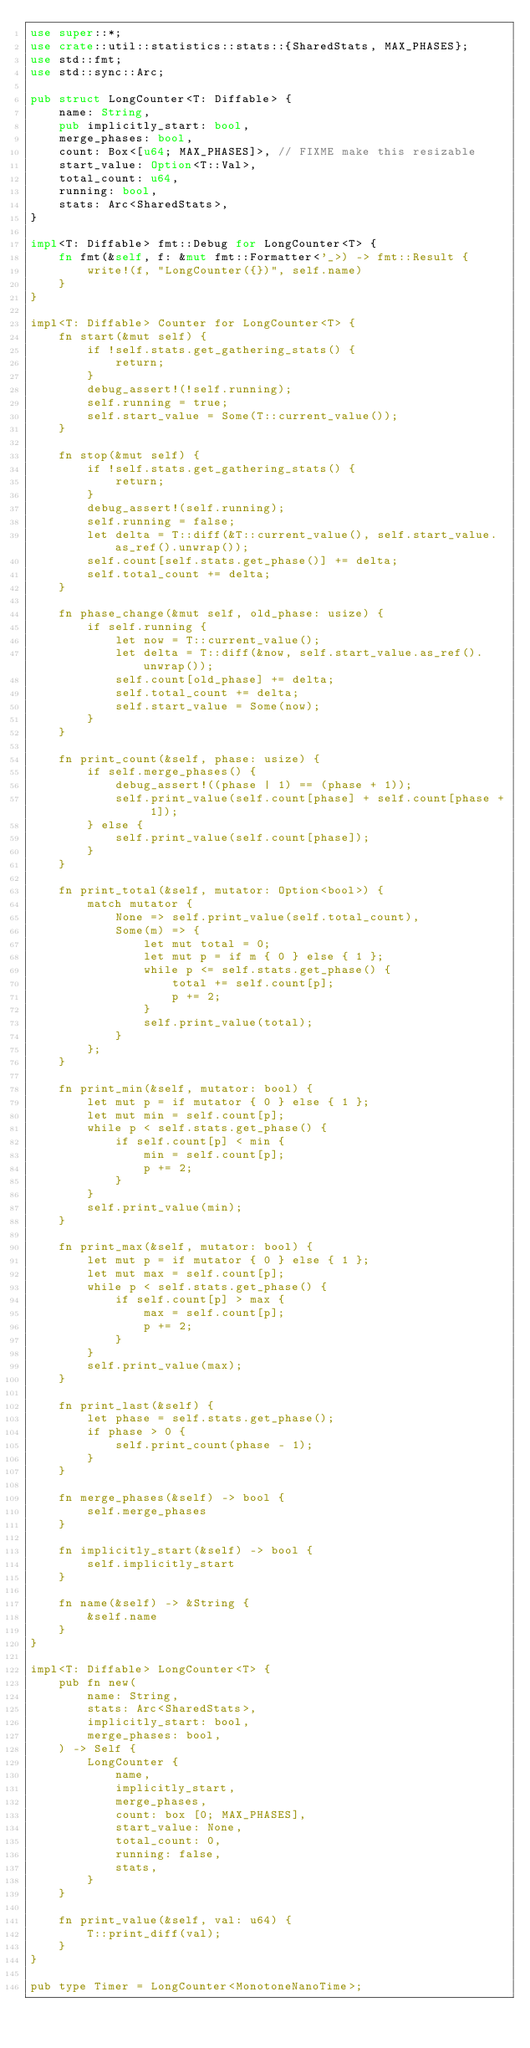Convert code to text. <code><loc_0><loc_0><loc_500><loc_500><_Rust_>use super::*;
use crate::util::statistics::stats::{SharedStats, MAX_PHASES};
use std::fmt;
use std::sync::Arc;

pub struct LongCounter<T: Diffable> {
    name: String,
    pub implicitly_start: bool,
    merge_phases: bool,
    count: Box<[u64; MAX_PHASES]>, // FIXME make this resizable
    start_value: Option<T::Val>,
    total_count: u64,
    running: bool,
    stats: Arc<SharedStats>,
}

impl<T: Diffable> fmt::Debug for LongCounter<T> {
    fn fmt(&self, f: &mut fmt::Formatter<'_>) -> fmt::Result {
        write!(f, "LongCounter({})", self.name)
    }
}

impl<T: Diffable> Counter for LongCounter<T> {
    fn start(&mut self) {
        if !self.stats.get_gathering_stats() {
            return;
        }
        debug_assert!(!self.running);
        self.running = true;
        self.start_value = Some(T::current_value());
    }

    fn stop(&mut self) {
        if !self.stats.get_gathering_stats() {
            return;
        }
        debug_assert!(self.running);
        self.running = false;
        let delta = T::diff(&T::current_value(), self.start_value.as_ref().unwrap());
        self.count[self.stats.get_phase()] += delta;
        self.total_count += delta;
    }

    fn phase_change(&mut self, old_phase: usize) {
        if self.running {
            let now = T::current_value();
            let delta = T::diff(&now, self.start_value.as_ref().unwrap());
            self.count[old_phase] += delta;
            self.total_count += delta;
            self.start_value = Some(now);
        }
    }

    fn print_count(&self, phase: usize) {
        if self.merge_phases() {
            debug_assert!((phase | 1) == (phase + 1));
            self.print_value(self.count[phase] + self.count[phase + 1]);
        } else {
            self.print_value(self.count[phase]);
        }
    }

    fn print_total(&self, mutator: Option<bool>) {
        match mutator {
            None => self.print_value(self.total_count),
            Some(m) => {
                let mut total = 0;
                let mut p = if m { 0 } else { 1 };
                while p <= self.stats.get_phase() {
                    total += self.count[p];
                    p += 2;
                }
                self.print_value(total);
            }
        };
    }

    fn print_min(&self, mutator: bool) {
        let mut p = if mutator { 0 } else { 1 };
        let mut min = self.count[p];
        while p < self.stats.get_phase() {
            if self.count[p] < min {
                min = self.count[p];
                p += 2;
            }
        }
        self.print_value(min);
    }

    fn print_max(&self, mutator: bool) {
        let mut p = if mutator { 0 } else { 1 };
        let mut max = self.count[p];
        while p < self.stats.get_phase() {
            if self.count[p] > max {
                max = self.count[p];
                p += 2;
            }
        }
        self.print_value(max);
    }

    fn print_last(&self) {
        let phase = self.stats.get_phase();
        if phase > 0 {
            self.print_count(phase - 1);
        }
    }

    fn merge_phases(&self) -> bool {
        self.merge_phases
    }

    fn implicitly_start(&self) -> bool {
        self.implicitly_start
    }

    fn name(&self) -> &String {
        &self.name
    }
}

impl<T: Diffable> LongCounter<T> {
    pub fn new(
        name: String,
        stats: Arc<SharedStats>,
        implicitly_start: bool,
        merge_phases: bool,
    ) -> Self {
        LongCounter {
            name,
            implicitly_start,
            merge_phases,
            count: box [0; MAX_PHASES],
            start_value: None,
            total_count: 0,
            running: false,
            stats,
        }
    }

    fn print_value(&self, val: u64) {
        T::print_diff(val);
    }
}

pub type Timer = LongCounter<MonotoneNanoTime>;
</code> 